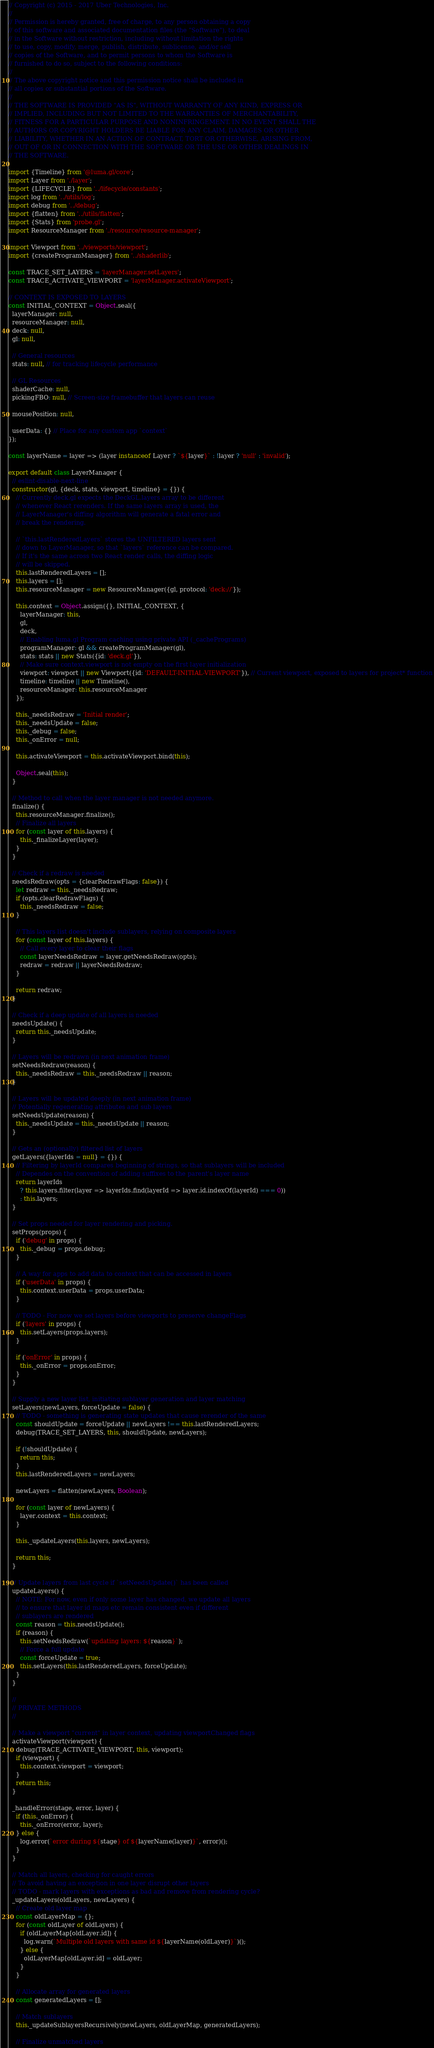Convert code to text. <code><loc_0><loc_0><loc_500><loc_500><_JavaScript_>// Copyright (c) 2015 - 2017 Uber Technologies, Inc.
//
// Permission is hereby granted, free of charge, to any person obtaining a copy
// of this software and associated documentation files (the "Software"), to deal
// in the Software without restriction, including without limitation the rights
// to use, copy, modify, merge, publish, distribute, sublicense, and/or sell
// copies of the Software, and to permit persons to whom the Software is
// furnished to do so, subject to the following conditions:
//
// The above copyright notice and this permission notice shall be included in
// all copies or substantial portions of the Software.
//
// THE SOFTWARE IS PROVIDED "AS IS", WITHOUT WARRANTY OF ANY KIND, EXPRESS OR
// IMPLIED, INCLUDING BUT NOT LIMITED TO THE WARRANTIES OF MERCHANTABILITY,
// FITNESS FOR A PARTICULAR PURPOSE AND NONINFRINGEMENT. IN NO EVENT SHALL THE
// AUTHORS OR COPYRIGHT HOLDERS BE LIABLE FOR ANY CLAIM, DAMAGES OR OTHER
// LIABILITY, WHETHER IN AN ACTION OF CONTRACT, TORT OR OTHERWISE, ARISING FROM,
// OUT OF OR IN CONNECTION WITH THE SOFTWARE OR THE USE OR OTHER DEALINGS IN
// THE SOFTWARE.

import {Timeline} from '@luma.gl/core';
import Layer from './layer';
import {LIFECYCLE} from '../lifecycle/constants';
import log from '../utils/log';
import debug from '../debug';
import {flatten} from '../utils/flatten';
import {Stats} from 'probe.gl';
import ResourceManager from './resource/resource-manager';

import Viewport from '../viewports/viewport';
import {createProgramManager} from '../shaderlib';

const TRACE_SET_LAYERS = 'layerManager.setLayers';
const TRACE_ACTIVATE_VIEWPORT = 'layerManager.activateViewport';

// CONTEXT IS EXPOSED TO LAYERS
const INITIAL_CONTEXT = Object.seal({
  layerManager: null,
  resourceManager: null,
  deck: null,
  gl: null,

  // General resources
  stats: null, // for tracking lifecycle performance

  // GL Resources
  shaderCache: null,
  pickingFBO: null, // Screen-size framebuffer that layers can reuse

  mousePosition: null,

  userData: {} // Place for any custom app `context`
});

const layerName = layer => (layer instanceof Layer ? `${layer}` : !layer ? 'null' : 'invalid');

export default class LayerManager {
  // eslint-disable-next-line
  constructor(gl, {deck, stats, viewport, timeline} = {}) {
    // Currently deck.gl expects the DeckGL.layers array to be different
    // whenever React rerenders. If the same layers array is used, the
    // LayerManager's diffing algorithm will generate a fatal error and
    // break the rendering.

    // `this.lastRenderedLayers` stores the UNFILTERED layers sent
    // down to LayerManager, so that `layers` reference can be compared.
    // If it's the same across two React render calls, the diffing logic
    // will be skipped.
    this.lastRenderedLayers = [];
    this.layers = [];
    this.resourceManager = new ResourceManager({gl, protocol: 'deck://'});

    this.context = Object.assign({}, INITIAL_CONTEXT, {
      layerManager: this,
      gl,
      deck,
      // Enabling luma.gl Program caching using private API (_cachePrograms)
      programManager: gl && createProgramManager(gl),
      stats: stats || new Stats({id: 'deck.gl'}),
      // Make sure context.viewport is not empty on the first layer initialization
      viewport: viewport || new Viewport({id: 'DEFAULT-INITIAL-VIEWPORT'}), // Current viewport, exposed to layers for project* function
      timeline: timeline || new Timeline(),
      resourceManager: this.resourceManager
    });

    this._needsRedraw = 'Initial render';
    this._needsUpdate = false;
    this._debug = false;
    this._onError = null;

    this.activateViewport = this.activateViewport.bind(this);

    Object.seal(this);
  }

  // Method to call when the layer manager is not needed anymore.
  finalize() {
    this.resourceManager.finalize();
    // Finalize all layers
    for (const layer of this.layers) {
      this._finalizeLayer(layer);
    }
  }

  // Check if a redraw is needed
  needsRedraw(opts = {clearRedrawFlags: false}) {
    let redraw = this._needsRedraw;
    if (opts.clearRedrawFlags) {
      this._needsRedraw = false;
    }

    // This layers list doesn't include sublayers, relying on composite layers
    for (const layer of this.layers) {
      // Call every layer to clear their flags
      const layerNeedsRedraw = layer.getNeedsRedraw(opts);
      redraw = redraw || layerNeedsRedraw;
    }

    return redraw;
  }

  // Check if a deep update of all layers is needed
  needsUpdate() {
    return this._needsUpdate;
  }

  // Layers will be redrawn (in next animation frame)
  setNeedsRedraw(reason) {
    this._needsRedraw = this._needsRedraw || reason;
  }

  // Layers will be updated deeply (in next animation frame)
  // Potentially regenerating attributes and sub layers
  setNeedsUpdate(reason) {
    this._needsUpdate = this._needsUpdate || reason;
  }

  // Gets an (optionally) filtered list of layers
  getLayers({layerIds = null} = {}) {
    // Filtering by layerId compares beginning of strings, so that sublayers will be included
    // Dependes on the convention of adding suffixes to the parent's layer name
    return layerIds
      ? this.layers.filter(layer => layerIds.find(layerId => layer.id.indexOf(layerId) === 0))
      : this.layers;
  }

  // Set props needed for layer rendering and picking.
  setProps(props) {
    if ('debug' in props) {
      this._debug = props.debug;
    }

    // A way for apps to add data to context that can be accessed in layers
    if ('userData' in props) {
      this.context.userData = props.userData;
    }

    // TODO - For now we set layers before viewports to preserve changeFlags
    if ('layers' in props) {
      this.setLayers(props.layers);
    }

    if ('onError' in props) {
      this._onError = props.onError;
    }
  }

  // Supply a new layer list, initiating sublayer generation and layer matching
  setLayers(newLayers, forceUpdate = false) {
    // TODO - something is generating state updates that cause rerender of the same
    const shouldUpdate = forceUpdate || newLayers !== this.lastRenderedLayers;
    debug(TRACE_SET_LAYERS, this, shouldUpdate, newLayers);

    if (!shouldUpdate) {
      return this;
    }
    this.lastRenderedLayers = newLayers;

    newLayers = flatten(newLayers, Boolean);

    for (const layer of newLayers) {
      layer.context = this.context;
    }

    this._updateLayers(this.layers, newLayers);

    return this;
  }

  // Update layers from last cycle if `setNeedsUpdate()` has been called
  updateLayers() {
    // NOTE: For now, even if only some layer has changed, we update all layers
    // to ensure that layer id maps etc remain consistent even if different
    // sublayers are rendered
    const reason = this.needsUpdate();
    if (reason) {
      this.setNeedsRedraw(`updating layers: ${reason}`);
      // Force a full update
      const forceUpdate = true;
      this.setLayers(this.lastRenderedLayers, forceUpdate);
    }
  }

  //
  // PRIVATE METHODS
  //

  // Make a viewport "current" in layer context, updating viewportChanged flags
  activateViewport(viewport) {
    debug(TRACE_ACTIVATE_VIEWPORT, this, viewport);
    if (viewport) {
      this.context.viewport = viewport;
    }
    return this;
  }

  _handleError(stage, error, layer) {
    if (this._onError) {
      this._onError(error, layer);
    } else {
      log.error(`error during ${stage} of ${layerName(layer)}`, error)();
    }
  }

  // Match all layers, checking for caught errors
  // To avoid having an exception in one layer disrupt other layers
  // TODO - mark layers with exceptions as bad and remove from rendering cycle?
  _updateLayers(oldLayers, newLayers) {
    // Create old layer map
    const oldLayerMap = {};
    for (const oldLayer of oldLayers) {
      if (oldLayerMap[oldLayer.id]) {
        log.warn(`Multiple old layers with same id ${layerName(oldLayer)}`)();
      } else {
        oldLayerMap[oldLayer.id] = oldLayer;
      }
    }

    // Allocate array for generated layers
    const generatedLayers = [];

    // Match sublayers
    this._updateSublayersRecursively(newLayers, oldLayerMap, generatedLayers);

    // Finalize unmatched layers</code> 